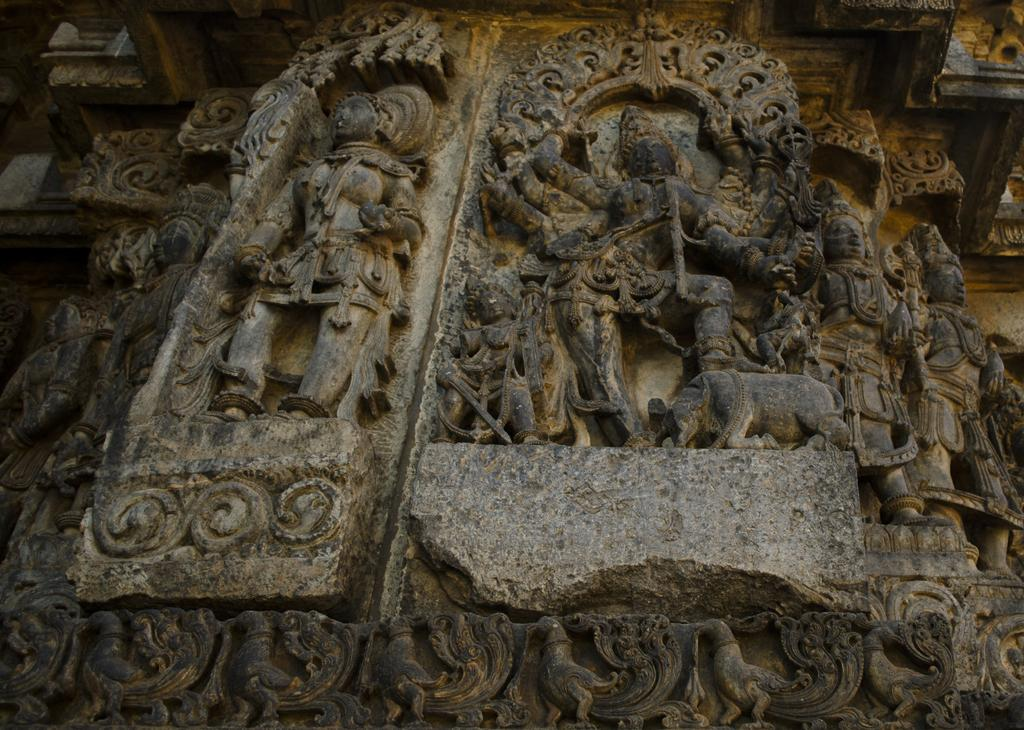What type of artwork can be seen in the image? There are sculptures in the image. What material is being used for the artwork in the image? There are carvings on a rock in the image, so the material is likely stone. What is the credit distribution for the aftermath of the event depicted in the image? There is no event or credit distribution mentioned in the image; it simply features sculptures and carvings on a rock. 